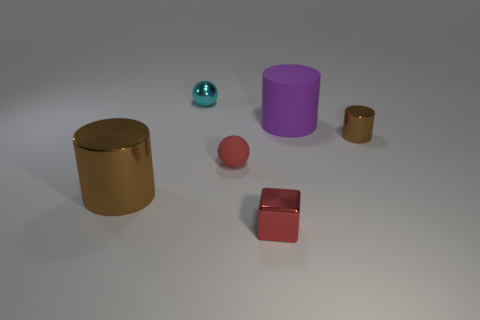There is a cylinder that is in front of the big matte thing and right of the big brown thing; how big is it? The cylinder in question appears to be medium-sized relative to the other objects in the image. It is significantly larger than the small teal sphere to its left and the smaller brown cylinder to its right, but smaller than the large gold cylinder and the large red matte cube. Estimating its dimensions without a reference scale is challenging, but in the context provided by the other objects, it would be reasonable to describe it as having a moderate size. 